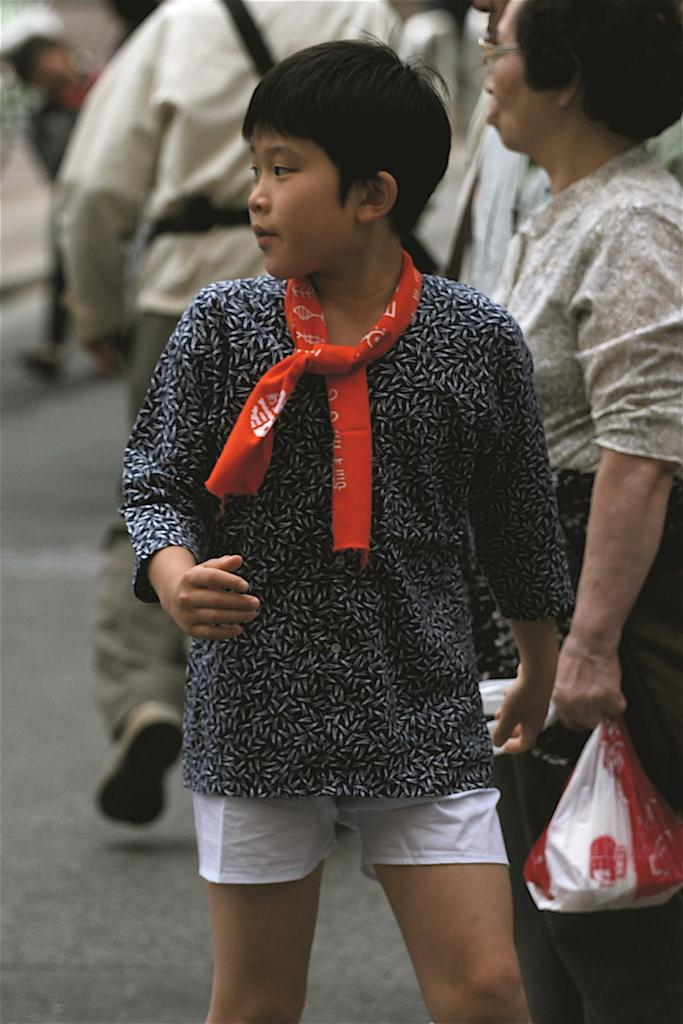What is happening in the image involving the group of people? Some people are standing, while others are walking on the road. Can you describe any objects visible in the image? There is a plastic cover visible in the image. How would you describe the background of the image? The background of the image is blurry. What type of brake is being used by the hen in the image? There is no hen present in the image, so it is not possible to determine what type of brake it might be using. 